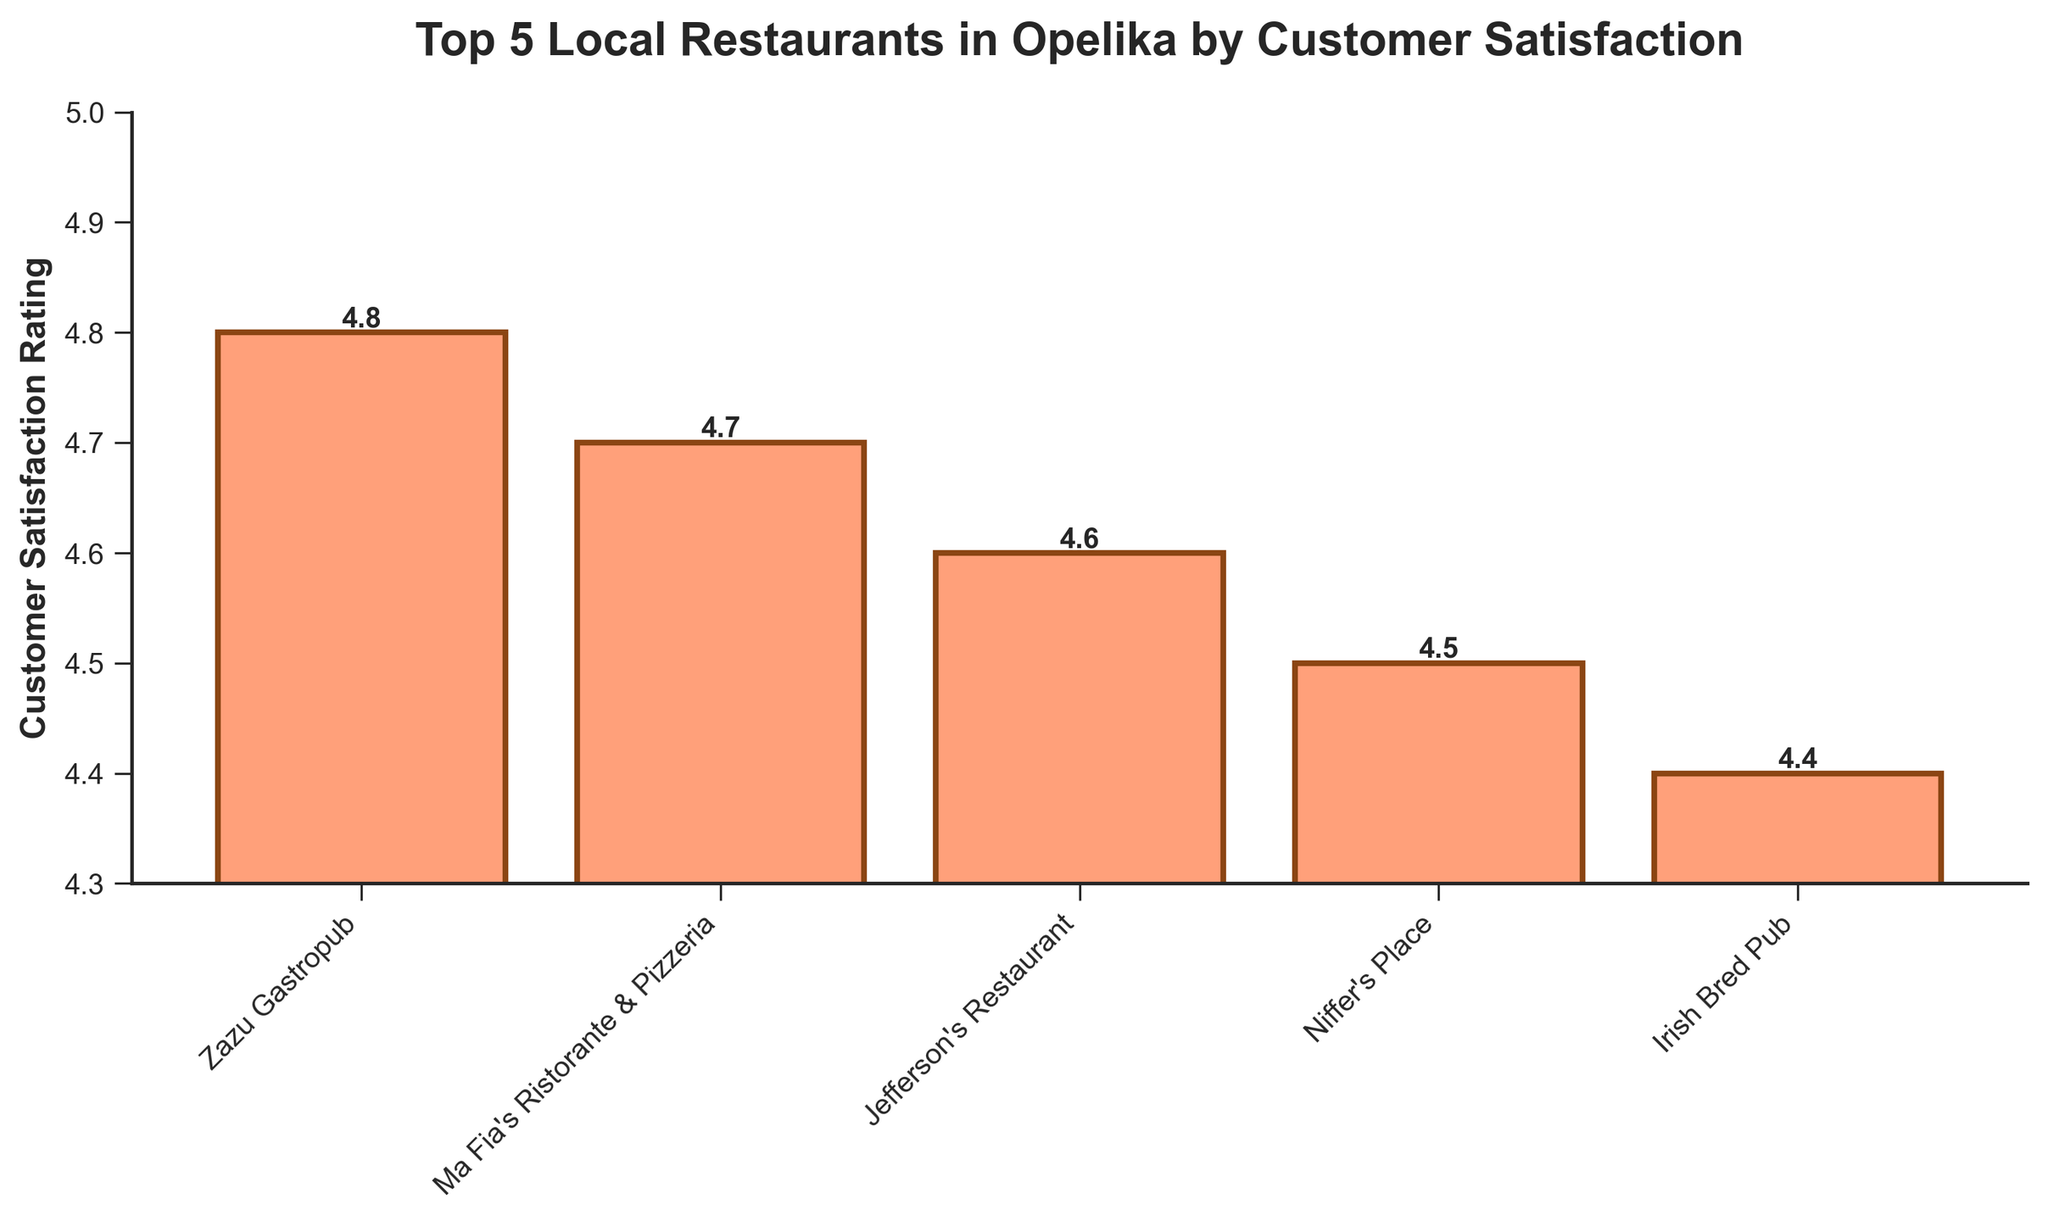Which restaurant has the highest customer satisfaction rating? The bar for Zazu Gastropub is the tallest, indicating it has the highest customer satisfaction rating of 4.8.
Answer: Zazu Gastropub How many restaurants have a customer satisfaction rating of 4.6 or higher? Zazu Gastropub, Ma Fia's Ristorante & Pizzeria, and Jefferson's Restaurant all have ratings of 4.6 or higher as indicated by the heights of their bars.
Answer: 3 Which restaurant has the lowest customer satisfaction rating? The bar for Irish Bred Pub is the shortest, indicating it has the lowest customer satisfaction rating of 4.4.
Answer: Irish Bred Pub What is the difference in customer satisfaction ratings between the highest-rated and the lowest-rated restaurant? Zazu Gastropub has a rating of 4.8 and Irish Bred Pub has a rating of 4.4; the difference is 4.8 - 4.4 = 0.4.
Answer: 0.4 What is the average customer satisfaction rating for these top 5 restaurants? Sum the ratings (4.8 + 4.7 + 4.6 + 4.5 + 4.4) to get 23, then divide by 5: 23 / 5 = 4.6.
Answer: 4.6 Is Ma Fia's Ristorante & Pizzeria's customer satisfaction rating higher than Niffer's Place's rating? The bar for Ma Fia's Ristorante & Pizzeria (4.7) is taller than the bar for Niffer's Place (4.5).
Answer: Yes What is the sum of the customer satisfaction ratings for Jefferson's Restaurant and Irish Bred Pub? Jefferson's Restaurant has a rating of 4.6 and Irish Bred Pub has a rating of 4.4; their sum is 4.6 + 4.4 = 9.
Answer: 9 Which two restaurants have the closest customer satisfaction ratings? Jefferson's Restaurant (4.6) and Niffer's Place (4.5) have the closest ratings with just a 0.1 difference.
Answer: Jefferson's Restaurant and Niffer's Place Are the ratings for any two restaurants equal? As per the figure, no two bars have the same height, indicating no two restaurants have the same rating.
Answer: No 